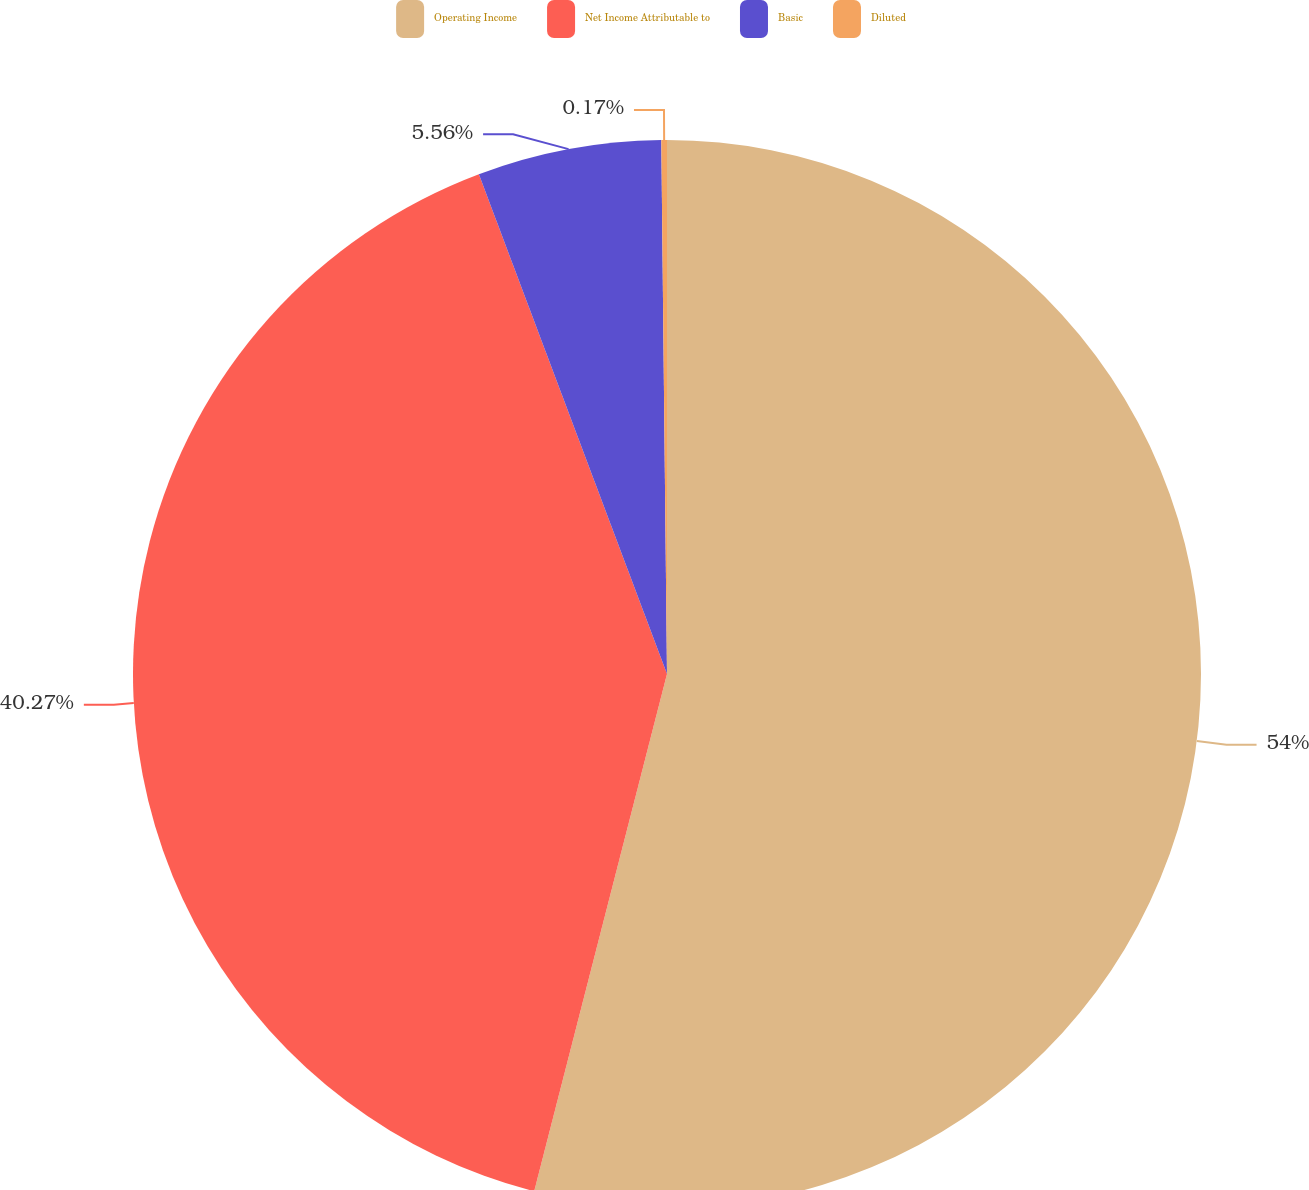Convert chart. <chart><loc_0><loc_0><loc_500><loc_500><pie_chart><fcel>Operating Income<fcel>Net Income Attributable to<fcel>Basic<fcel>Diluted<nl><fcel>54.0%<fcel>40.27%<fcel>5.56%<fcel>0.17%<nl></chart> 